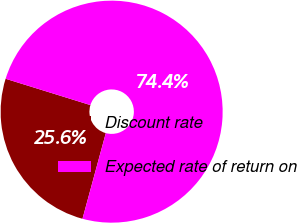<chart> <loc_0><loc_0><loc_500><loc_500><pie_chart><fcel>Discount rate<fcel>Expected rate of return on<nl><fcel>25.56%<fcel>74.44%<nl></chart> 